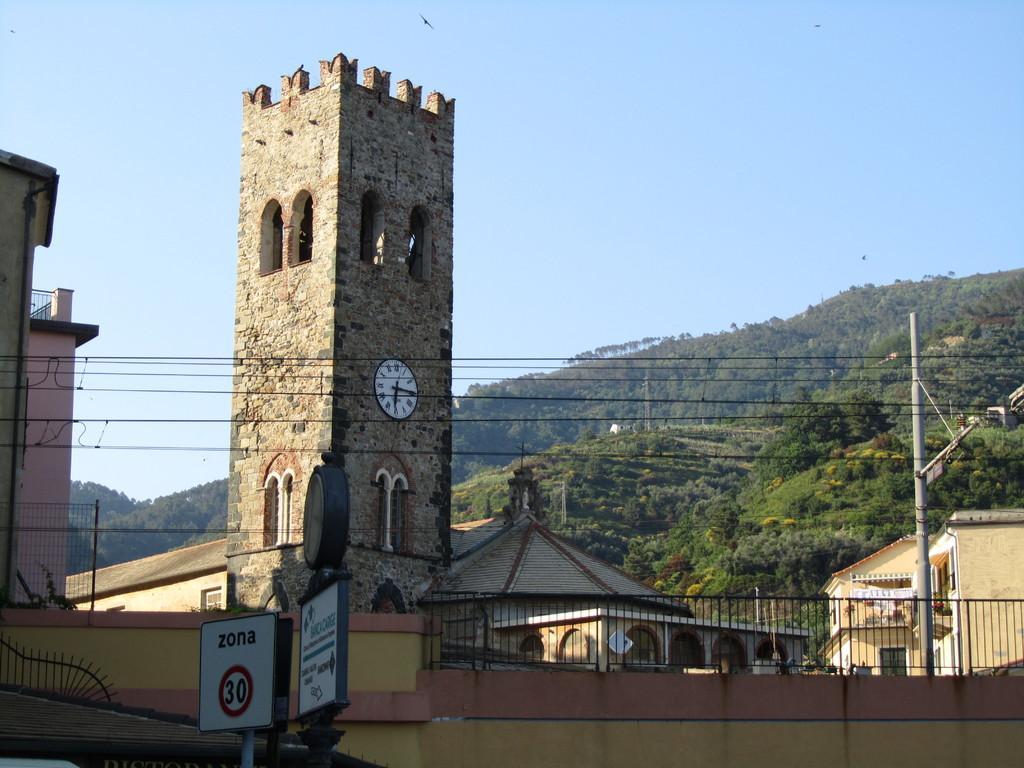In one or two sentences, can you explain what this image depicts? In the center of the image we can see building and clock tower. On the right side of the image we can see building and pole. On the left side of the image we can see sign boards, wall and building. In the background we can see trees, hills and sky. 